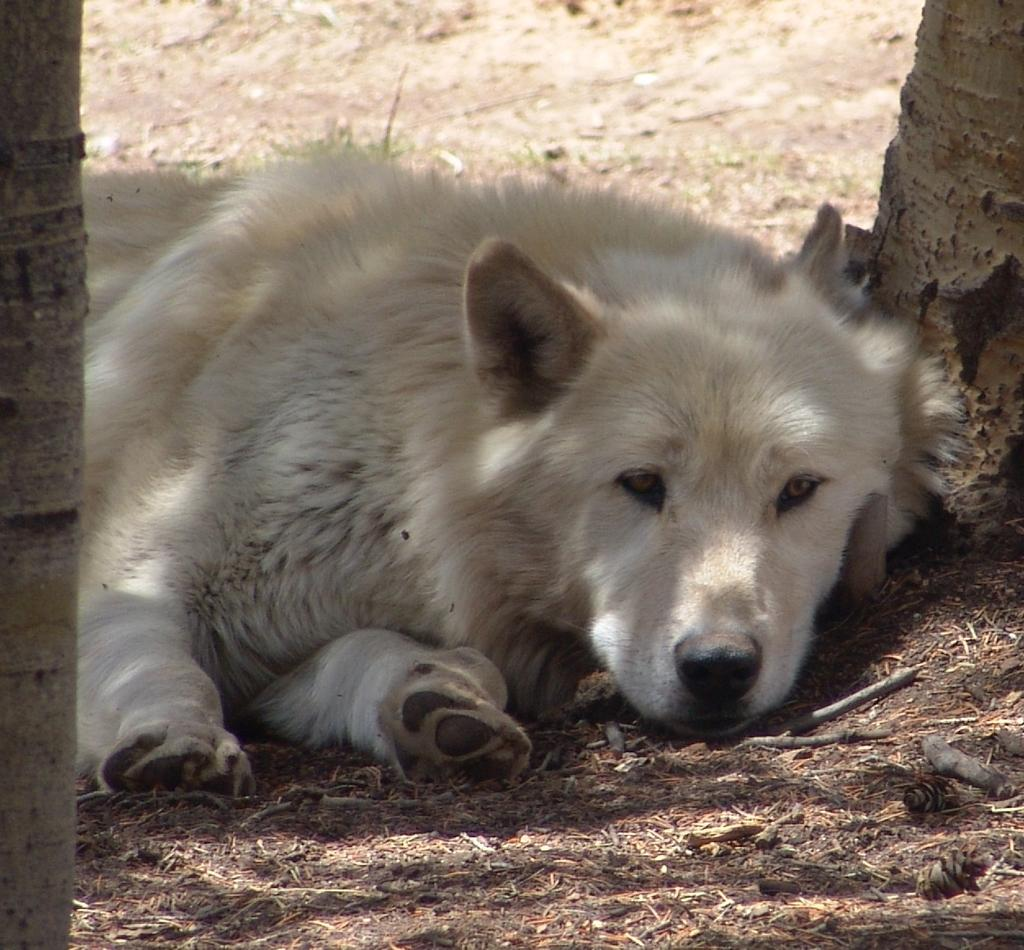What is the main subject in the center of the image? There is a dog in the center of the image. What type of terrain is visible at the bottom of the image? There is sand at the bottom of the image. How many trees are on each side of the image? There are two trees on the left side of the image and two trees on the right side of the image. What type of machine can be seen operating in the downtown area in the image? There is no machine or downtown area present in the image; it features a dog and trees in a sandy environment. 